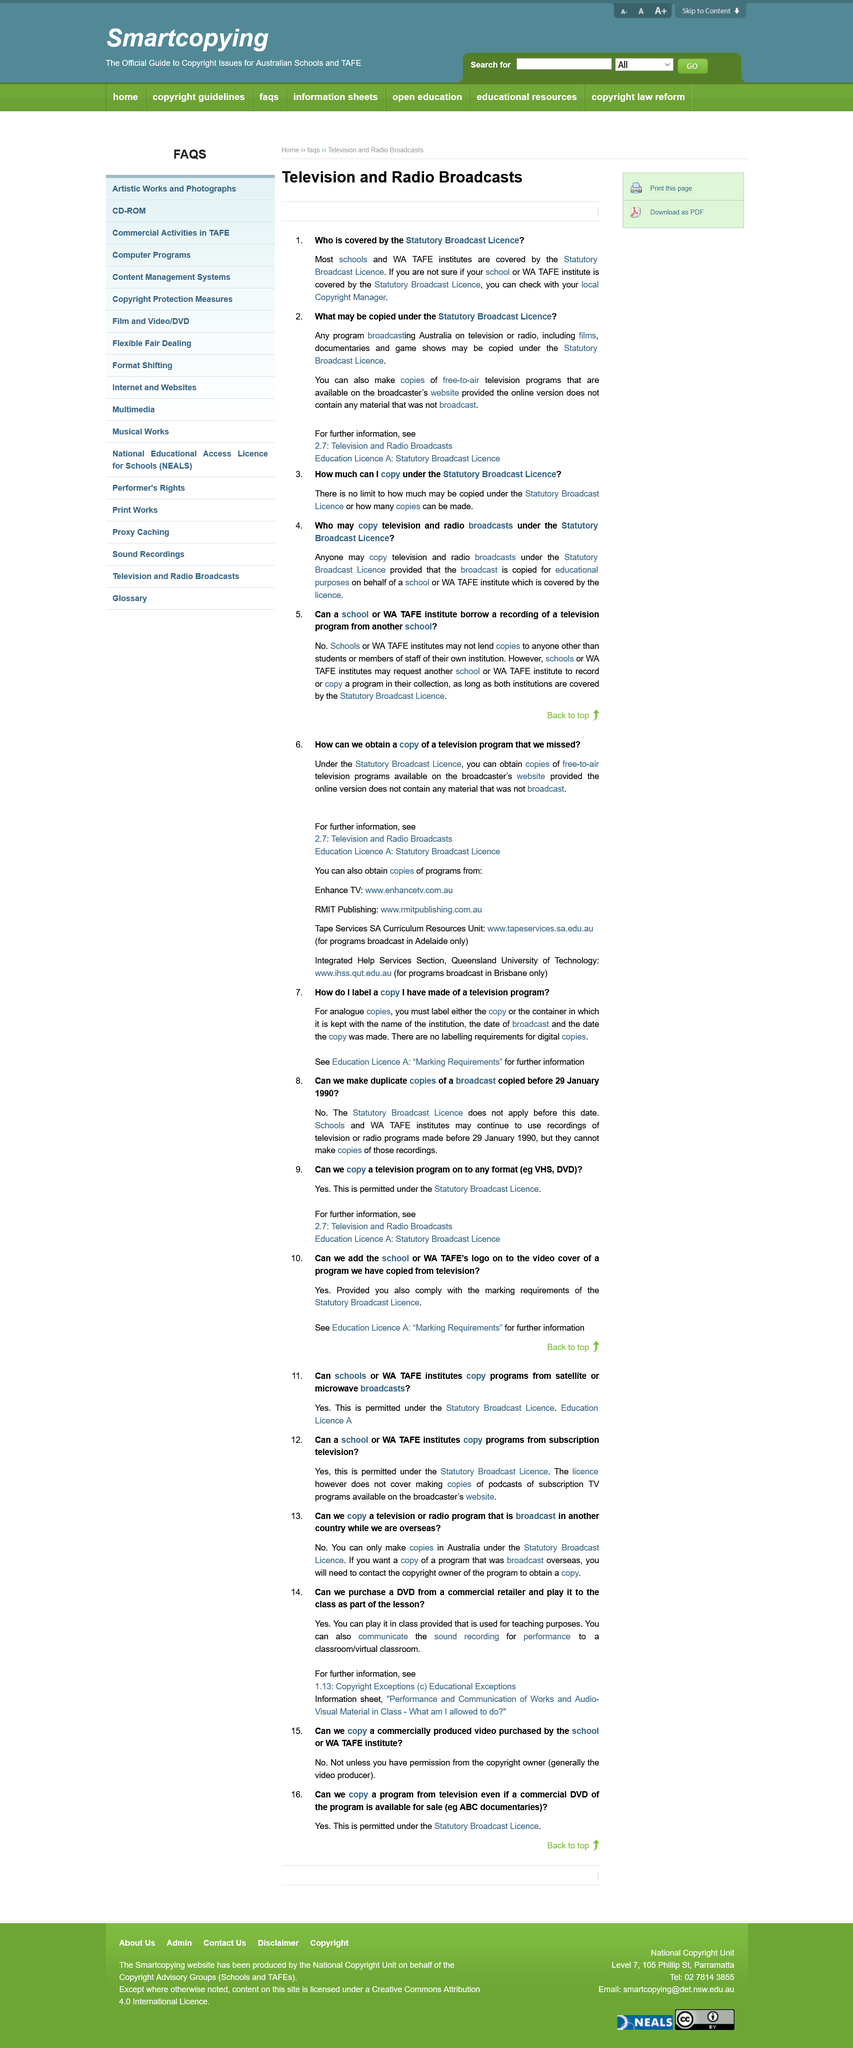Specify some key components in this picture. The copyright owner of a commercially produced video is generally the video producer. The marking requirements of the Statutory Broadcast Licence permit a school's logo to be added to the video cover of a program copied from television if the requirements are complied with. The Education License allows schools to copy programs from satellite or microwave broadcasts. If you were seeking additional information on incorporating purchased DVDs into a lesson for teaching, you would refer to the 1.13 Copyright Exceptions, specifically the Educational Exceptions. The Statutory Broadcast License does not allow the copying of radio programs broadcast in countries outside of Australia. 